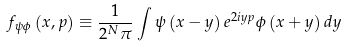<formula> <loc_0><loc_0><loc_500><loc_500>f _ { \psi \phi } \left ( x , p \right ) \equiv \frac { 1 } { 2 ^ { N } \pi } \int \psi \left ( x - y \right ) e ^ { 2 i y p } \phi \left ( x + y \right ) d y</formula> 